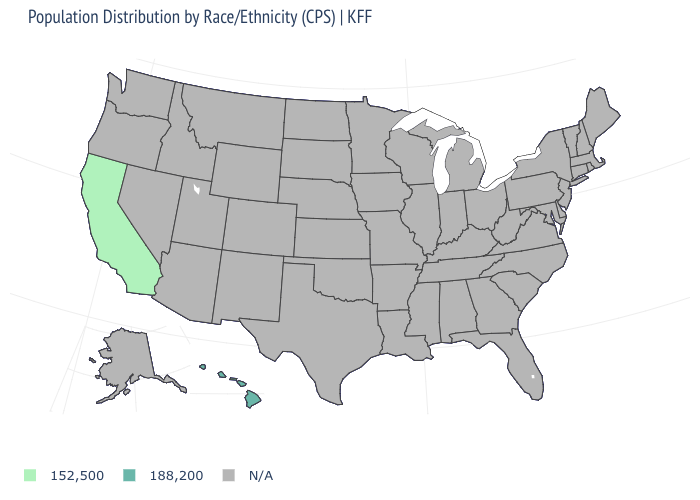Does the map have missing data?
Keep it brief. Yes. What is the lowest value in the West?
Concise answer only. 152,500. What is the value of Alaska?
Give a very brief answer. N/A. Name the states that have a value in the range 152,500?
Be succinct. California. Does California have the lowest value in the USA?
Concise answer only. Yes. How many symbols are there in the legend?
Answer briefly. 3. Does Hawaii have the highest value in the USA?
Quick response, please. Yes. What is the value of Minnesota?
Give a very brief answer. N/A. Is the legend a continuous bar?
Be succinct. No. Which states have the lowest value in the USA?
Write a very short answer. California. Does the map have missing data?
Concise answer only. Yes. What is the value of South Carolina?
Give a very brief answer. N/A. 